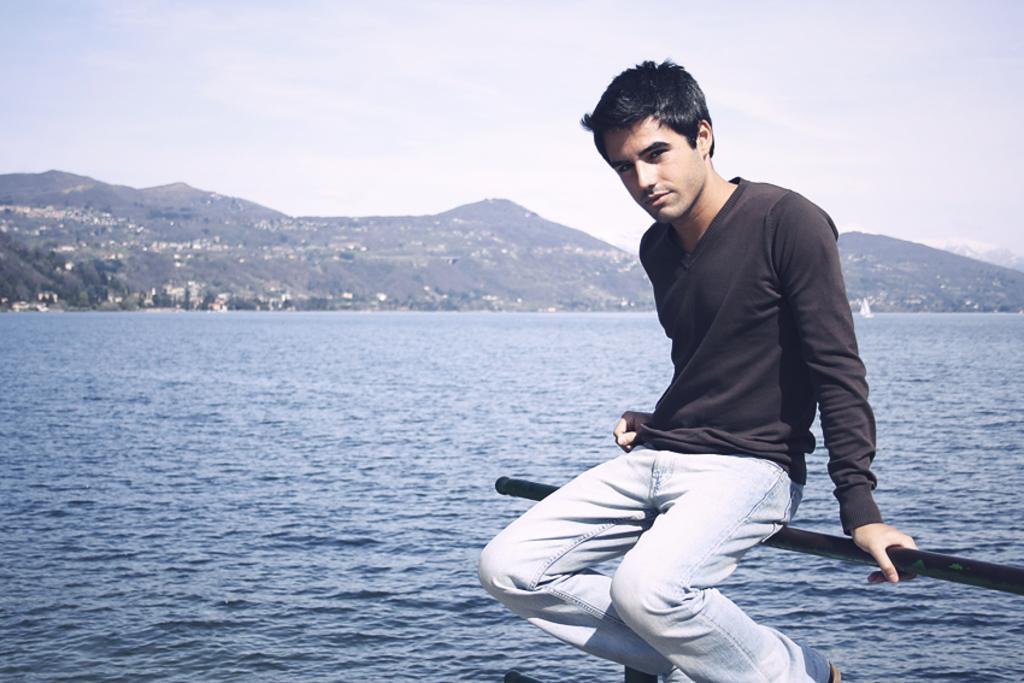Please provide a concise description of this image. In this image, we can see a person sitting on a pole. We can see some water and trees. There are a few houses and hills. We can also see the sky. 